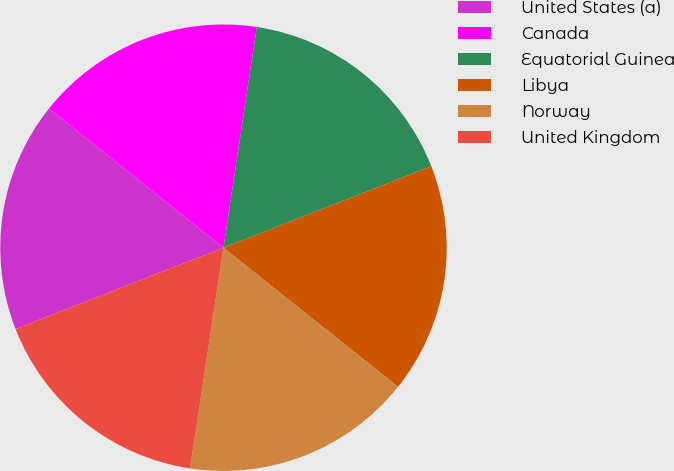Convert chart. <chart><loc_0><loc_0><loc_500><loc_500><pie_chart><fcel>United States (a)<fcel>Canada<fcel>Equatorial Guinea<fcel>Libya<fcel>Norway<fcel>United Kingdom<nl><fcel>16.65%<fcel>16.67%<fcel>16.67%<fcel>16.66%<fcel>16.68%<fcel>16.68%<nl></chart> 